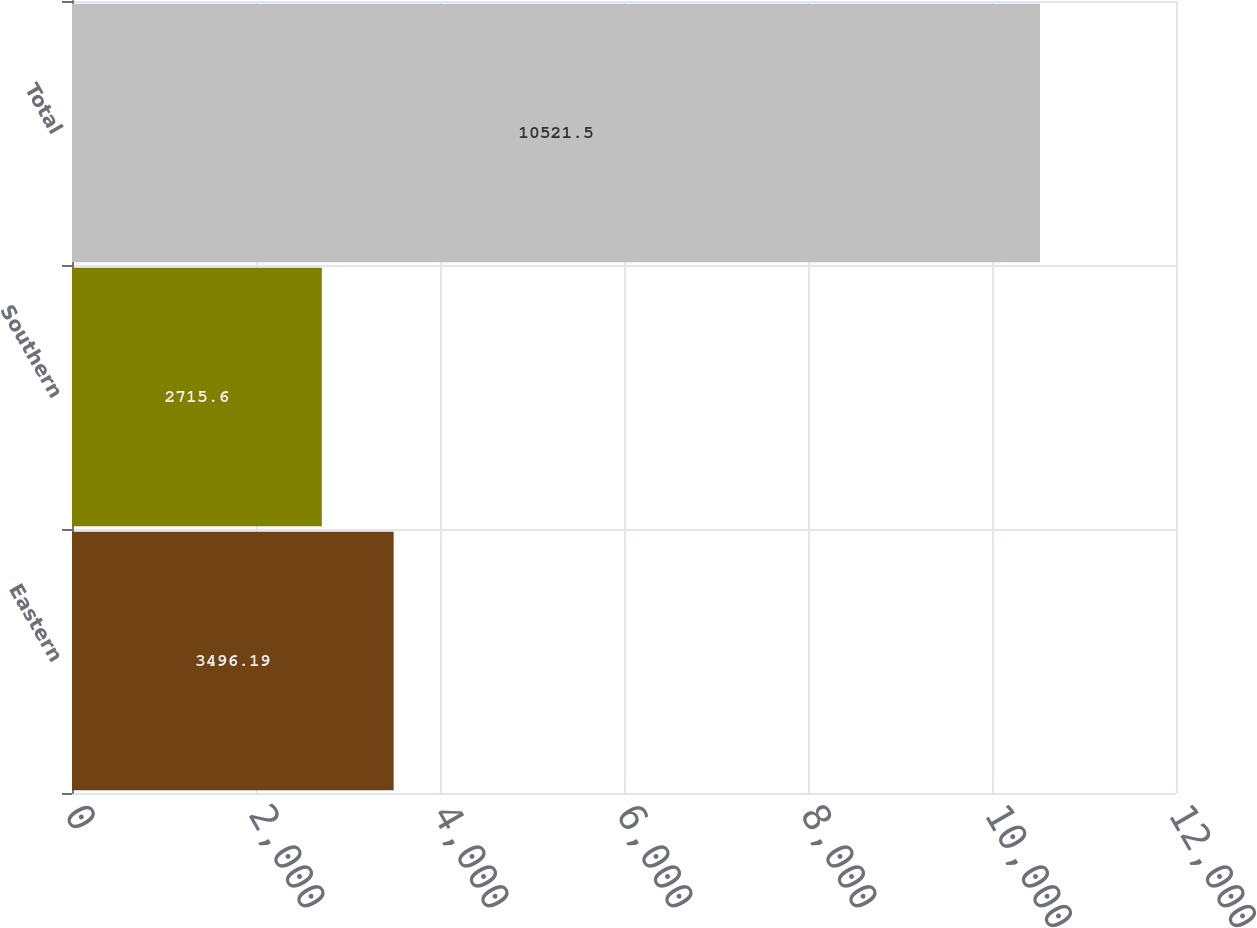Convert chart. <chart><loc_0><loc_0><loc_500><loc_500><bar_chart><fcel>Eastern<fcel>Southern<fcel>Total<nl><fcel>3496.19<fcel>2715.6<fcel>10521.5<nl></chart> 